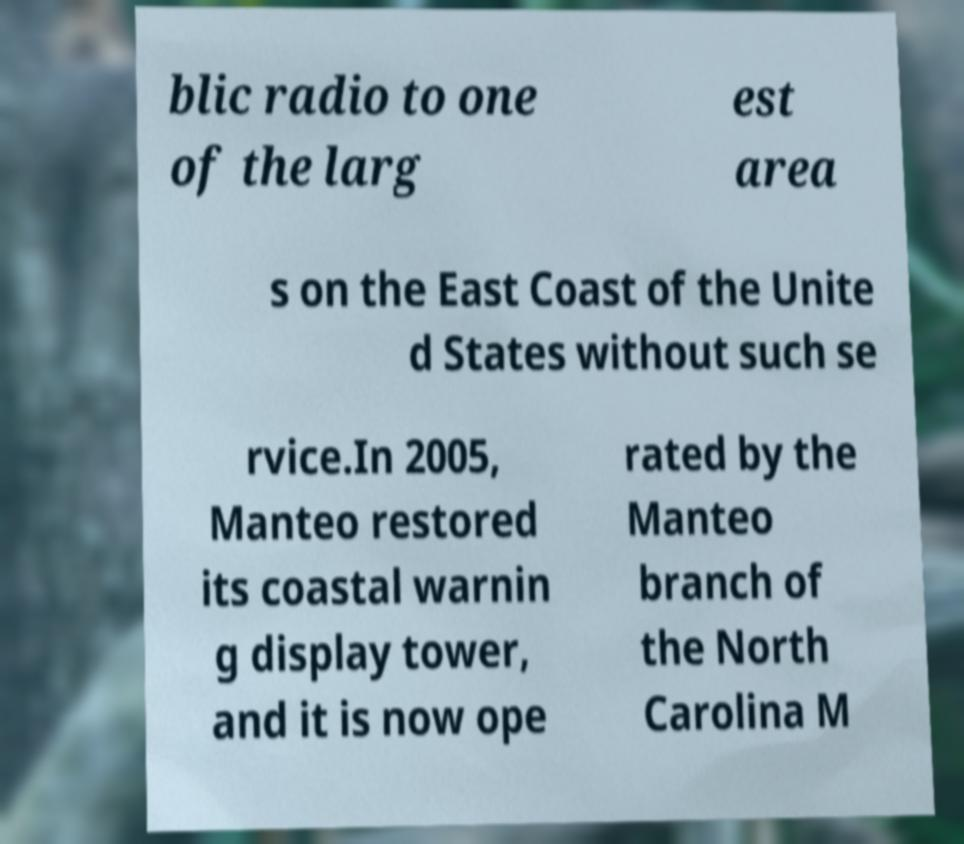What messages or text are displayed in this image? I need them in a readable, typed format. blic radio to one of the larg est area s on the East Coast of the Unite d States without such se rvice.In 2005, Manteo restored its coastal warnin g display tower, and it is now ope rated by the Manteo branch of the North Carolina M 